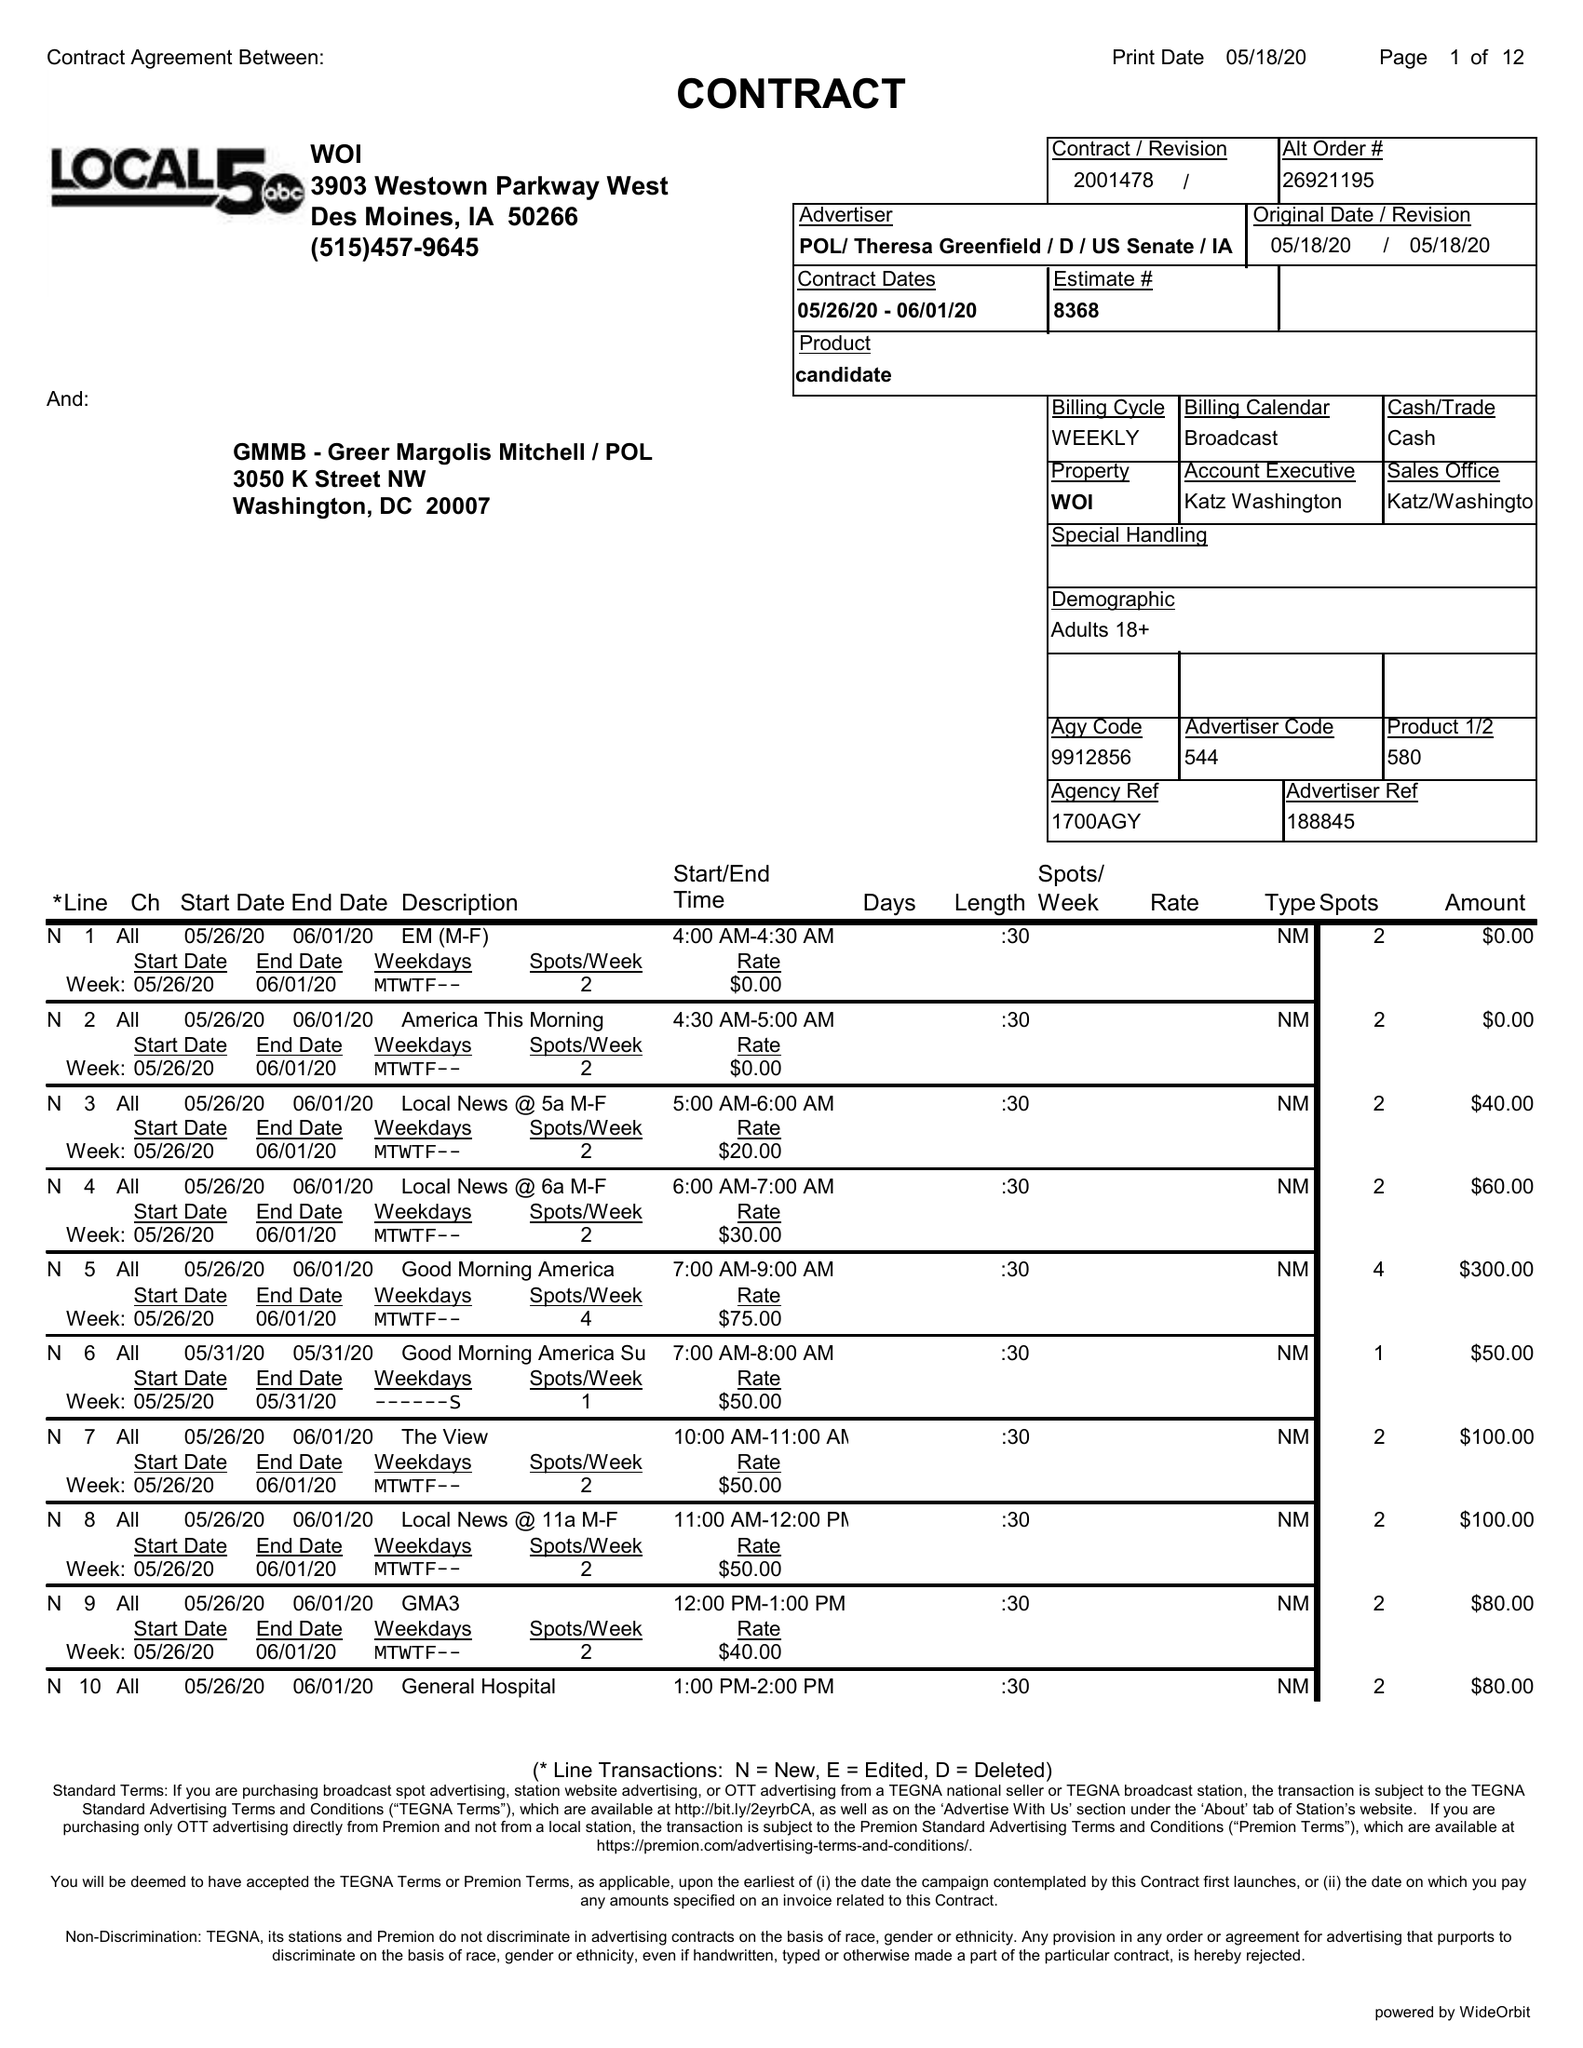What is the value for the flight_from?
Answer the question using a single word or phrase. 05/26/20 